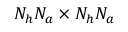<formula> <loc_0><loc_0><loc_500><loc_500>N _ { h } N _ { a } \times N _ { h } N _ { a }</formula> 